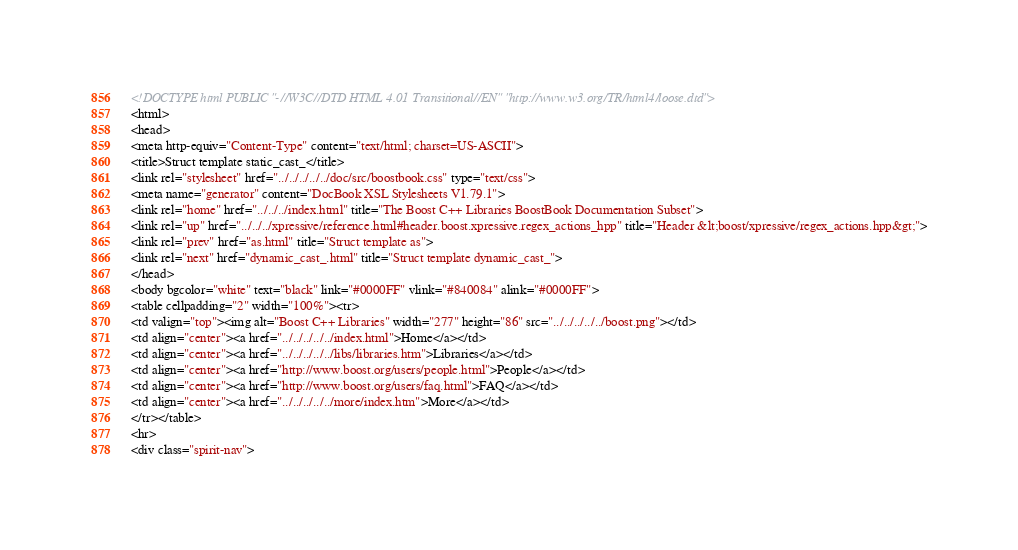Convert code to text. <code><loc_0><loc_0><loc_500><loc_500><_HTML_><!DOCTYPE html PUBLIC "-//W3C//DTD HTML 4.01 Transitional//EN" "http://www.w3.org/TR/html4/loose.dtd">
<html>
<head>
<meta http-equiv="Content-Type" content="text/html; charset=US-ASCII">
<title>Struct template static_cast_</title>
<link rel="stylesheet" href="../../../../../doc/src/boostbook.css" type="text/css">
<meta name="generator" content="DocBook XSL Stylesheets V1.79.1">
<link rel="home" href="../../../index.html" title="The Boost C++ Libraries BoostBook Documentation Subset">
<link rel="up" href="../../../xpressive/reference.html#header.boost.xpressive.regex_actions_hpp" title="Header &lt;boost/xpressive/regex_actions.hpp&gt;">
<link rel="prev" href="as.html" title="Struct template as">
<link rel="next" href="dynamic_cast_.html" title="Struct template dynamic_cast_">
</head>
<body bgcolor="white" text="black" link="#0000FF" vlink="#840084" alink="#0000FF">
<table cellpadding="2" width="100%"><tr>
<td valign="top"><img alt="Boost C++ Libraries" width="277" height="86" src="../../../../../boost.png"></td>
<td align="center"><a href="../../../../../index.html">Home</a></td>
<td align="center"><a href="../../../../../libs/libraries.htm">Libraries</a></td>
<td align="center"><a href="http://www.boost.org/users/people.html">People</a></td>
<td align="center"><a href="http://www.boost.org/users/faq.html">FAQ</a></td>
<td align="center"><a href="../../../../../more/index.htm">More</a></td>
</tr></table>
<hr>
<div class="spirit-nav"></code> 